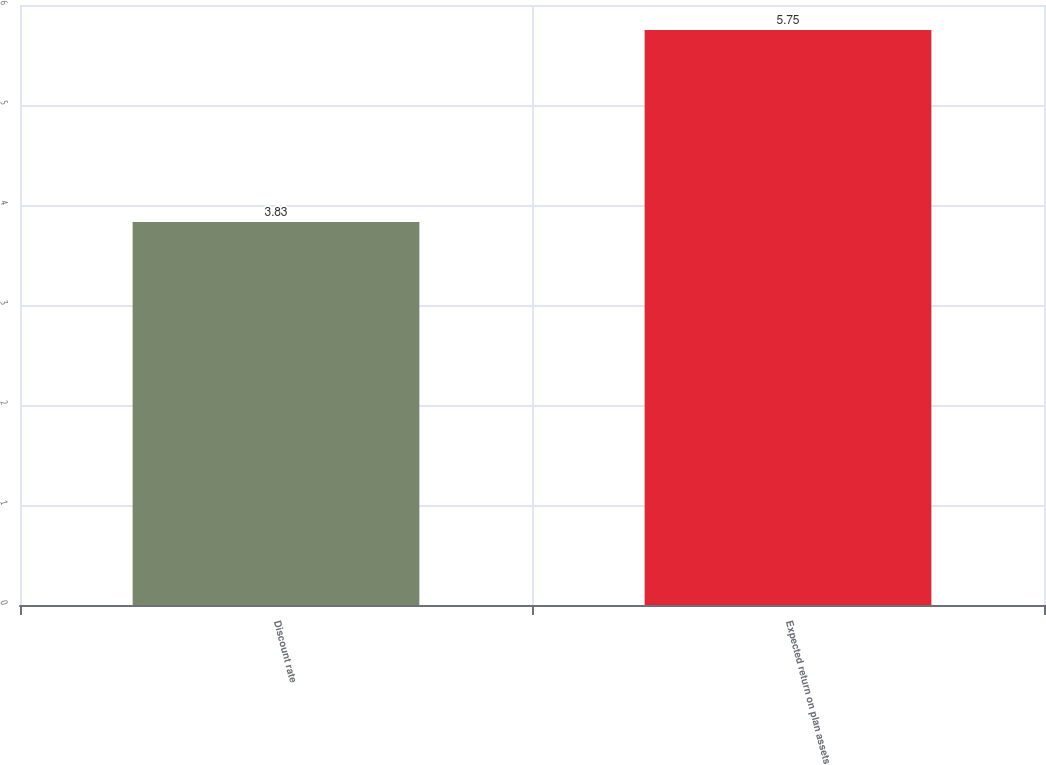Convert chart to OTSL. <chart><loc_0><loc_0><loc_500><loc_500><bar_chart><fcel>Discount rate<fcel>Expected return on plan assets<nl><fcel>3.83<fcel>5.75<nl></chart> 